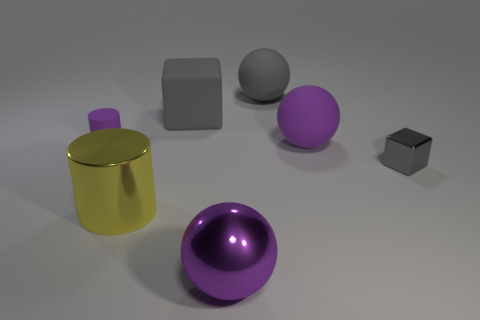Is the number of small metallic things behind the tiny shiny thing less than the number of purple objects in front of the tiny purple cylinder?
Give a very brief answer. Yes. What shape is the gray object to the right of the purple ball behind the metal thing behind the yellow thing?
Your answer should be very brief. Cube. Is the color of the cube to the right of the big purple shiny object the same as the block that is left of the gray sphere?
Give a very brief answer. Yes. What shape is the large matte thing that is the same color as the large shiny ball?
Provide a short and direct response. Sphere. What number of rubber things are either big blue things or big gray balls?
Your response must be concise. 1. There is a tiny object that is right of the purple thing left of the big purple thing in front of the yellow shiny cylinder; what is its color?
Give a very brief answer. Gray. There is another thing that is the same shape as the big yellow metal thing; what is its color?
Provide a succinct answer. Purple. Is there anything else that is the same color as the large metallic cylinder?
Offer a terse response. No. How many other things are made of the same material as the yellow thing?
Your response must be concise. 2. The purple rubber cylinder is what size?
Your answer should be very brief. Small. 